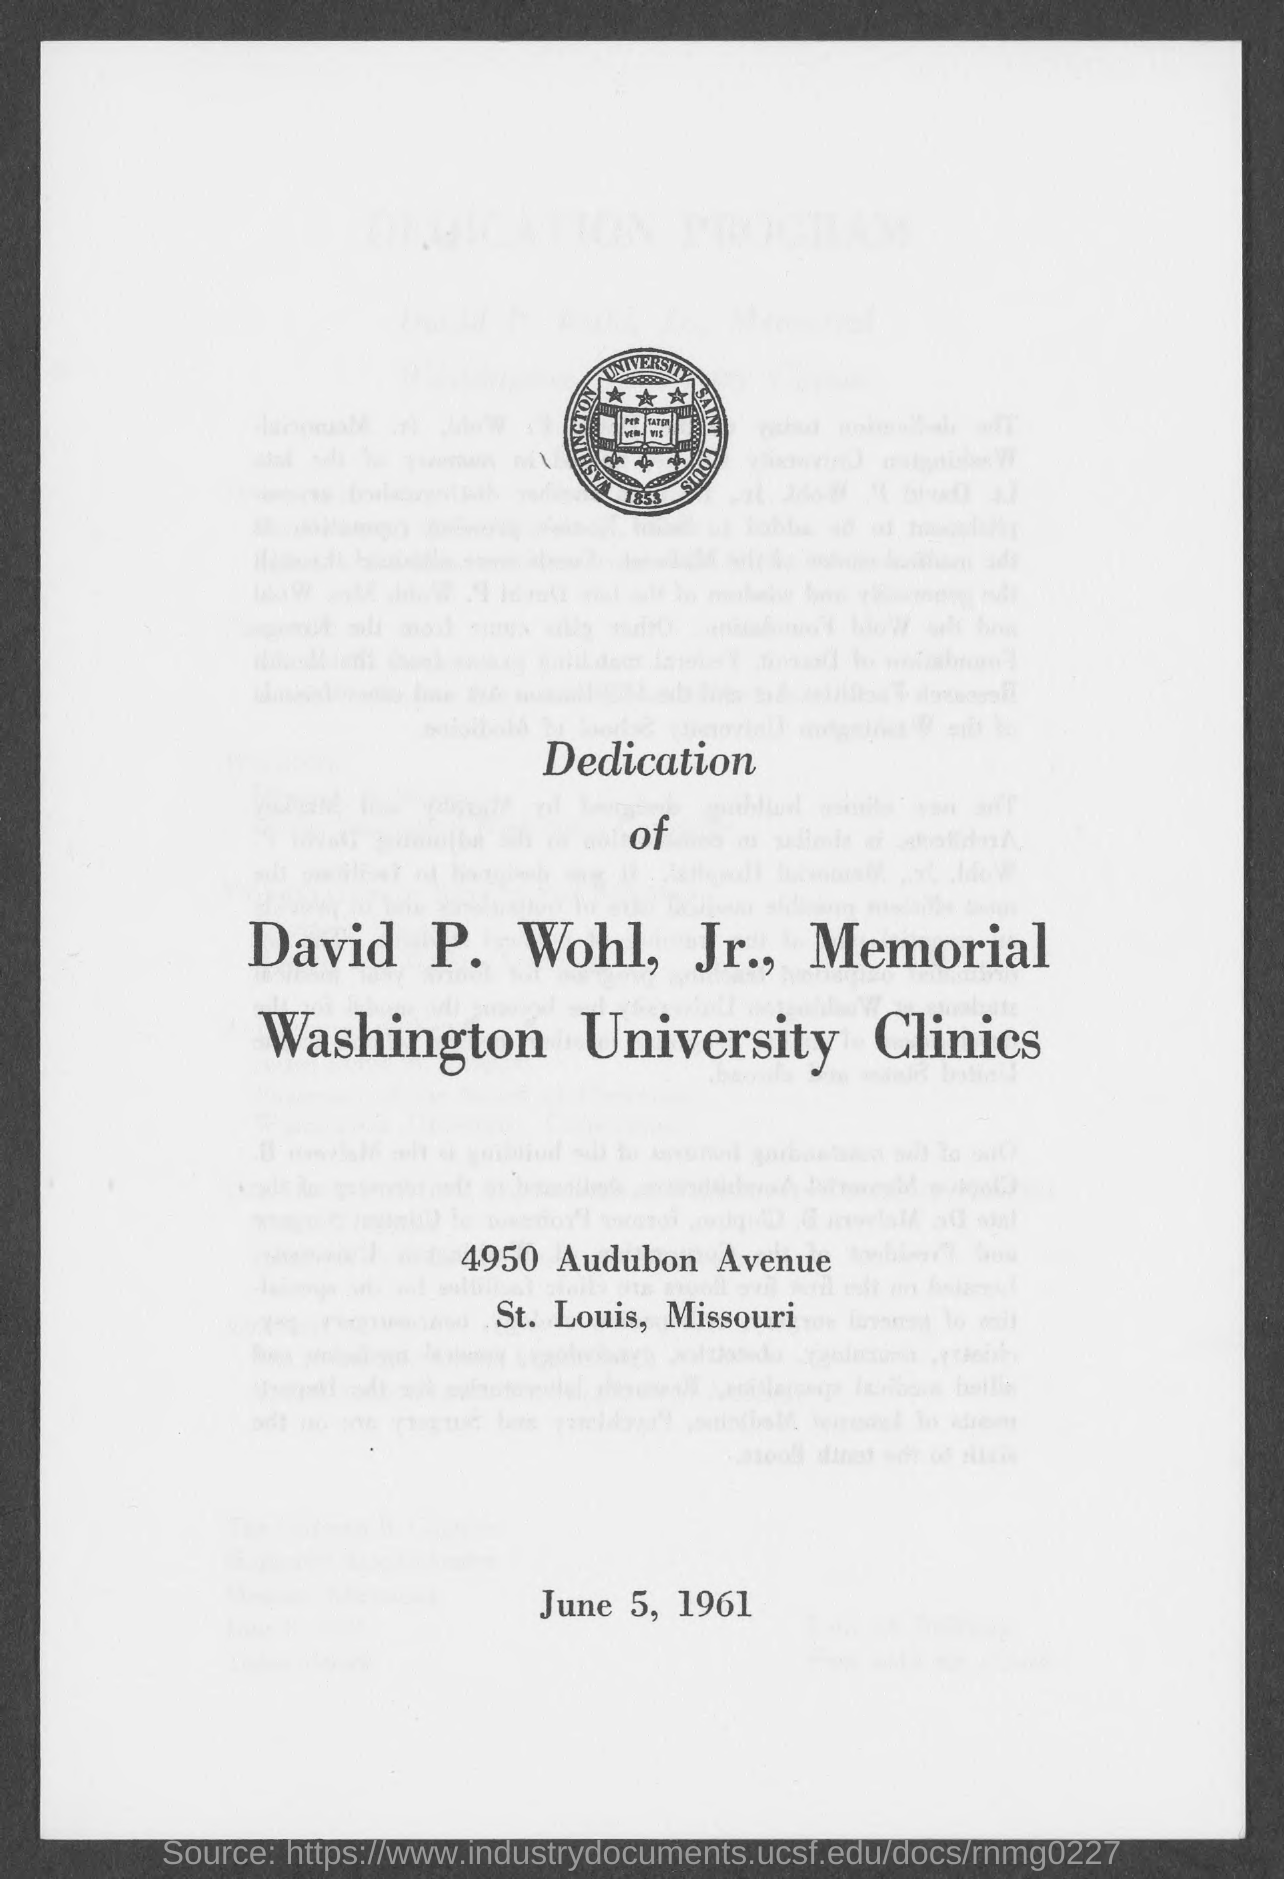Mention a couple of crucial points in this snapshot. The name of the university mentioned in the logo is Washington University. 